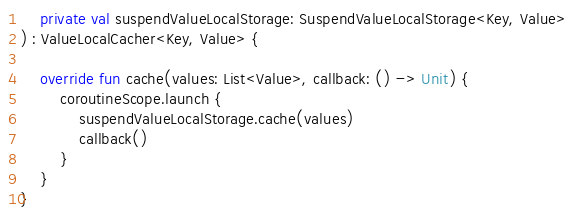Convert code to text. <code><loc_0><loc_0><loc_500><loc_500><_Kotlin_>    private val suspendValueLocalStorage: SuspendValueLocalStorage<Key, Value>
) : ValueLocalCacher<Key, Value> {

    override fun cache(values: List<Value>, callback: () -> Unit) {
        coroutineScope.launch {
            suspendValueLocalStorage.cache(values)
            callback()
        }
    }
}</code> 